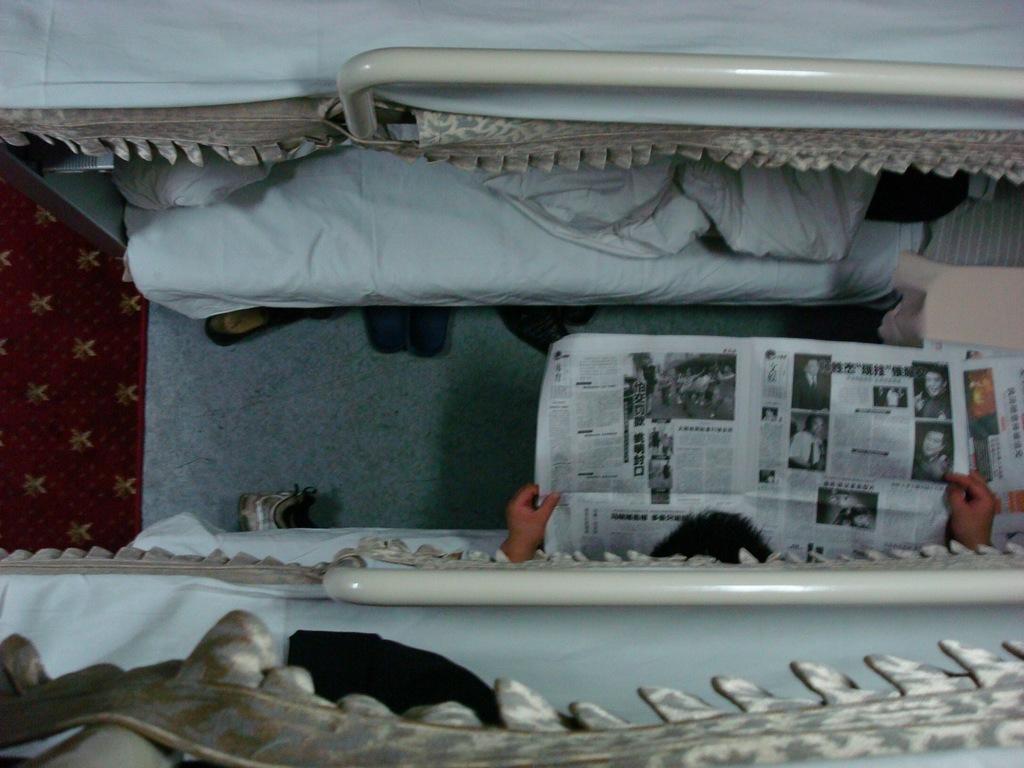Can you describe this image briefly? In this image there is a person sitting on the bed and he is reading the newspaper. Beside him there is another bed. On top of it there is a blanket. At the bottom of the image there are flip flops on the mat. 